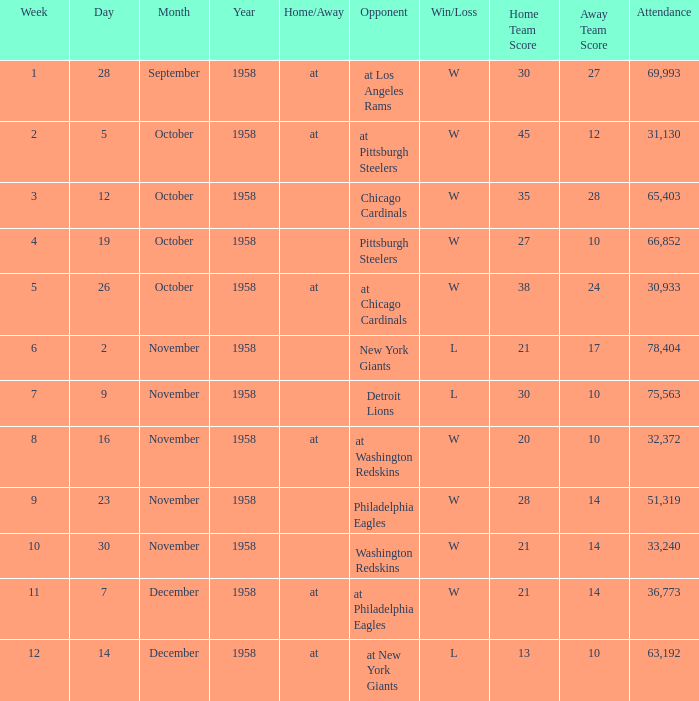What day had over 51,319 attending week 4? October 19, 1958. 